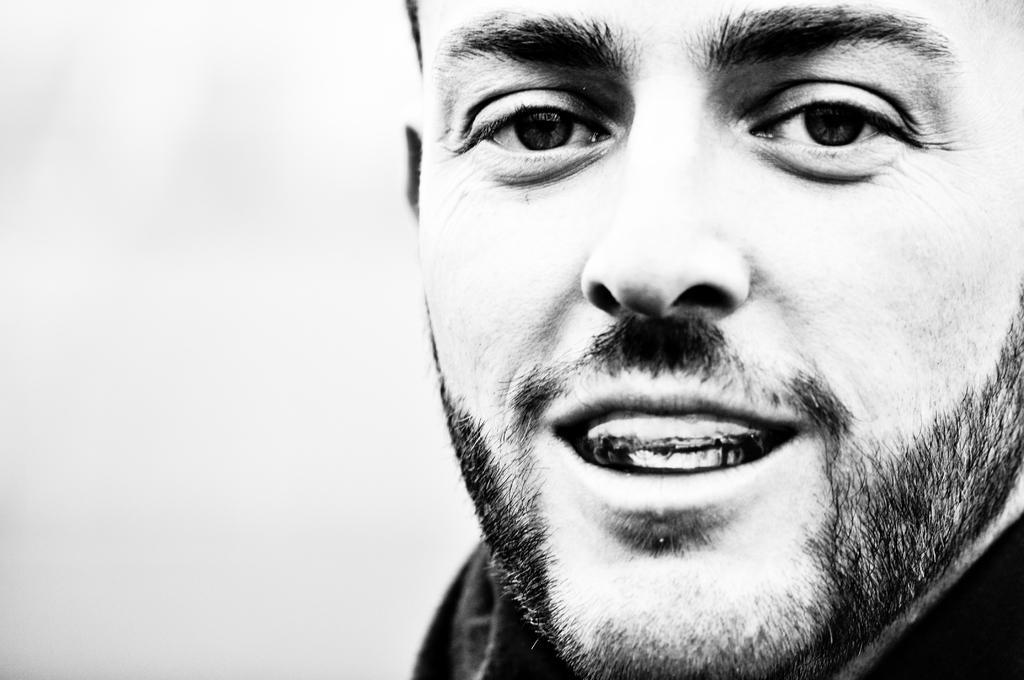Can you describe this image briefly? It is the black and white image in which we can see the face of a man. 